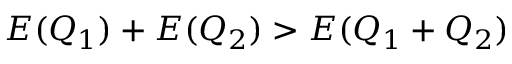Convert formula to latex. <formula><loc_0><loc_0><loc_500><loc_500>E ( Q _ { 1 } ) + E ( Q _ { 2 } ) > E ( Q _ { 1 } + Q _ { 2 } )</formula> 